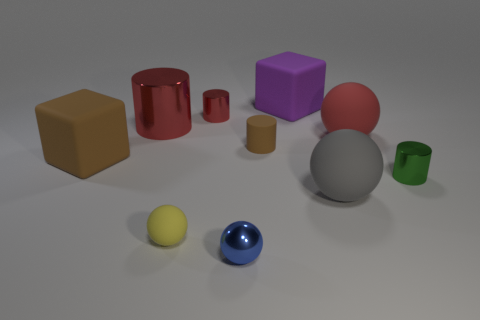What material is the big ball that is right of the large ball that is to the left of the big red rubber sphere? rubber 